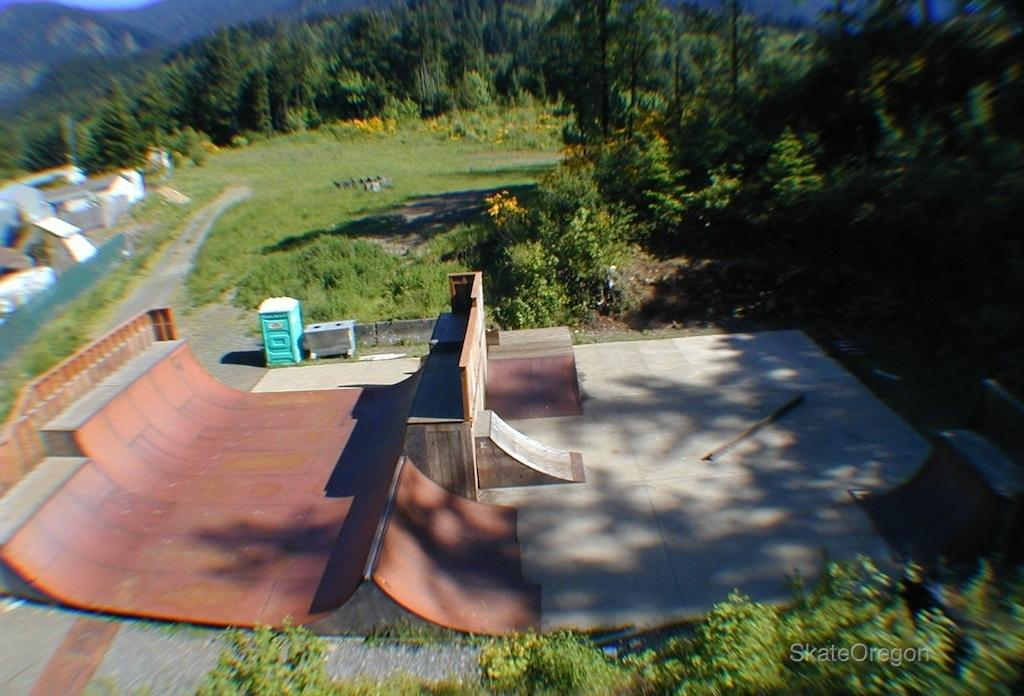What is the main feature of the image? There is a skate track in the image. What can be seen on the left side of the image? There are boxes on the left side of the image. What type of natural environment is visible in the background of the image? There are trees, grass, plants, and flowers in the background of the image. Where is the text located in the image? The text is at the right bottom of the image. What type of produce is being harvested in the image? There is no produce being harvested in the image; it features a skate track and other elements. What nation is represented in the image? The image does not represent any specific nation; it is a general scene with a skate track and other elements. 